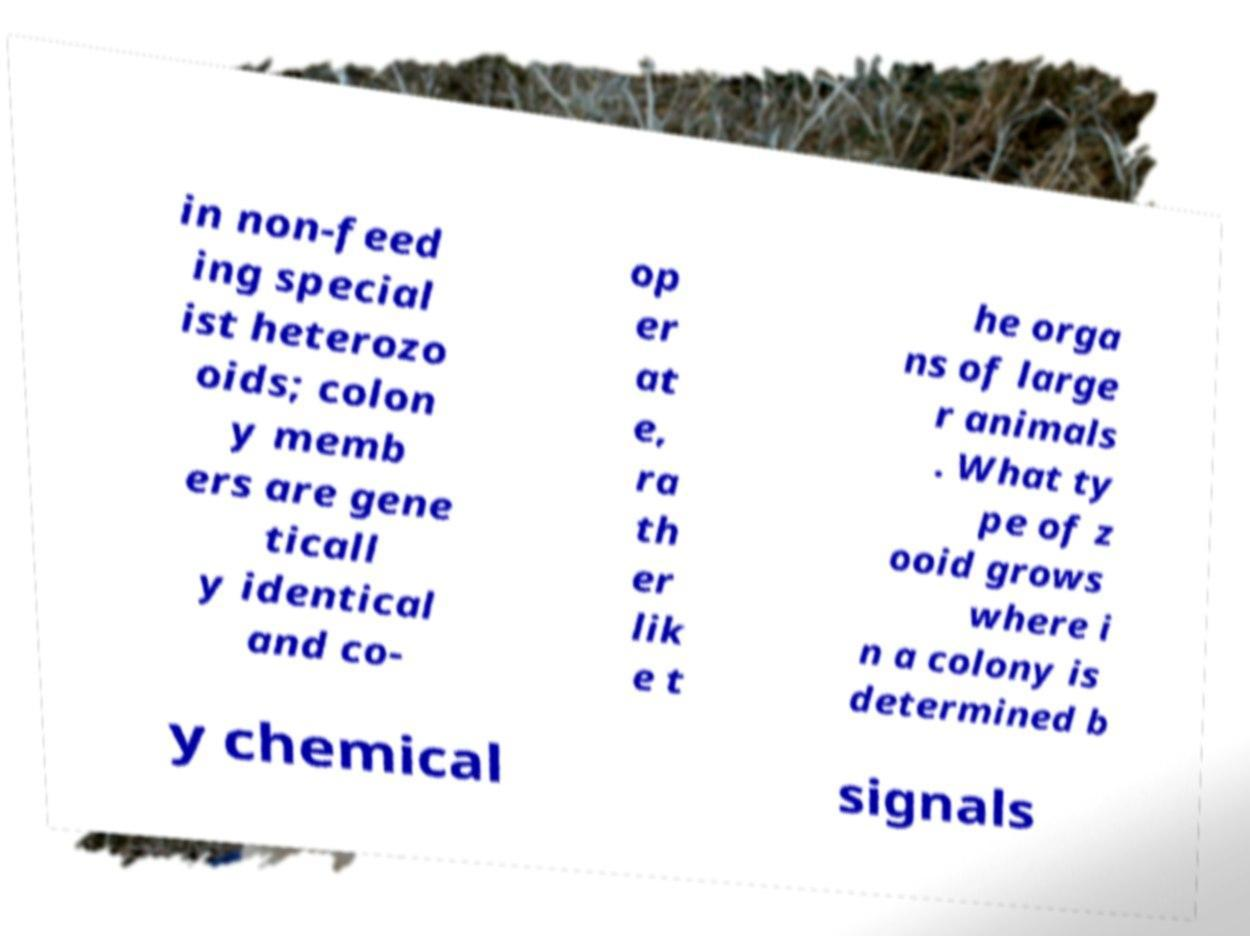What messages or text are displayed in this image? I need them in a readable, typed format. in non-feed ing special ist heterozo oids; colon y memb ers are gene ticall y identical and co- op er at e, ra th er lik e t he orga ns of large r animals . What ty pe of z ooid grows where i n a colony is determined b y chemical signals 